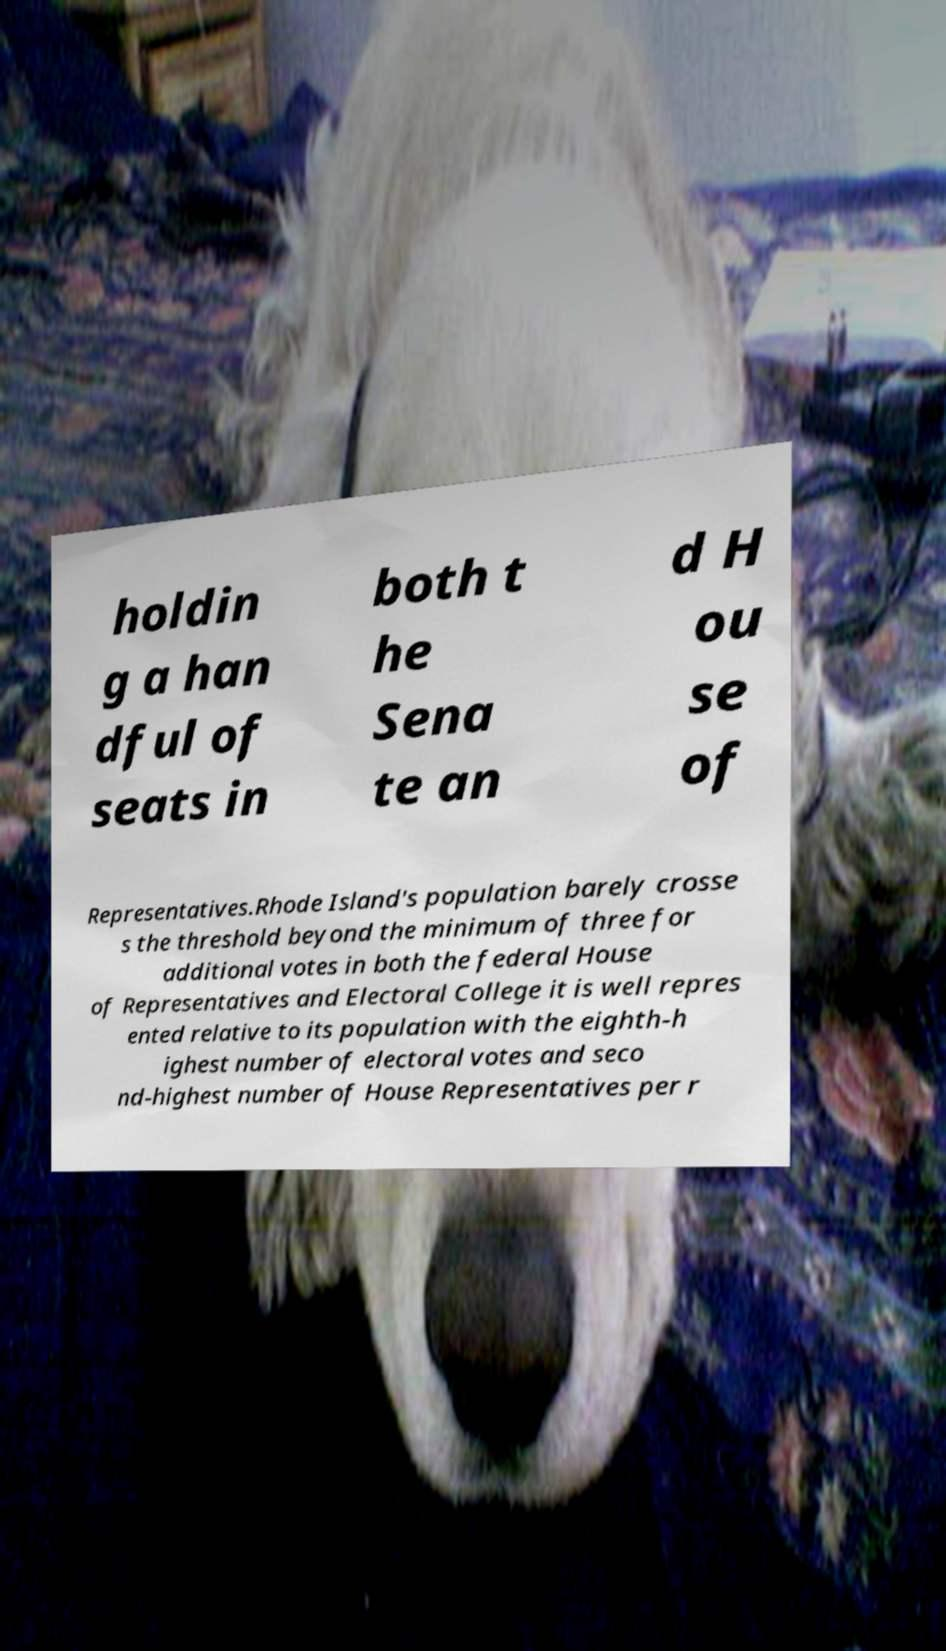Could you extract and type out the text from this image? holdin g a han dful of seats in both t he Sena te an d H ou se of Representatives.Rhode Island's population barely crosse s the threshold beyond the minimum of three for additional votes in both the federal House of Representatives and Electoral College it is well repres ented relative to its population with the eighth-h ighest number of electoral votes and seco nd-highest number of House Representatives per r 